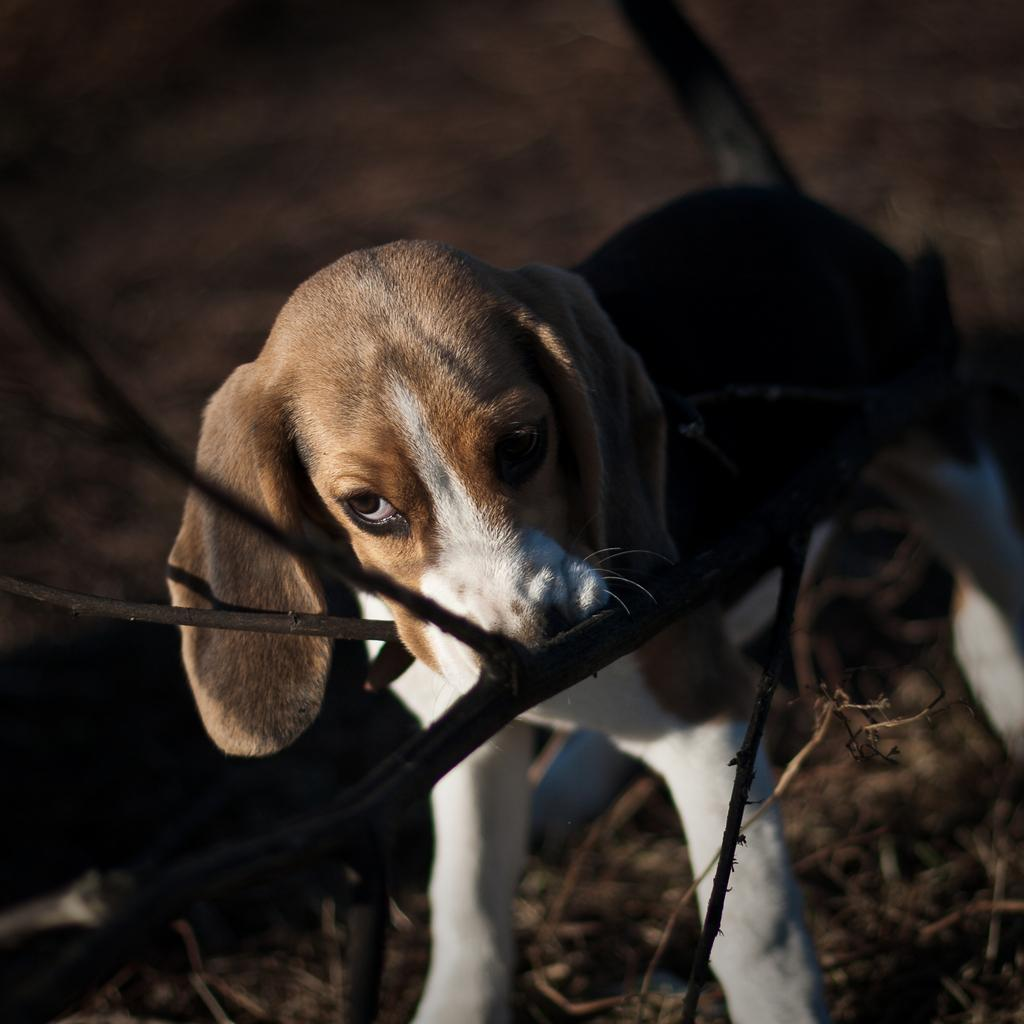What animal is present in the image? There is a dog in the image. Can you describe the appearance of the dog? The dog is brown and white in color. Where is the dog located in the image? The dog is standing near the branch of a tree. What type of wheel is the dog using to move around in the image? There is no wheel present in the image, and the dog is not using any wheel to move around. 